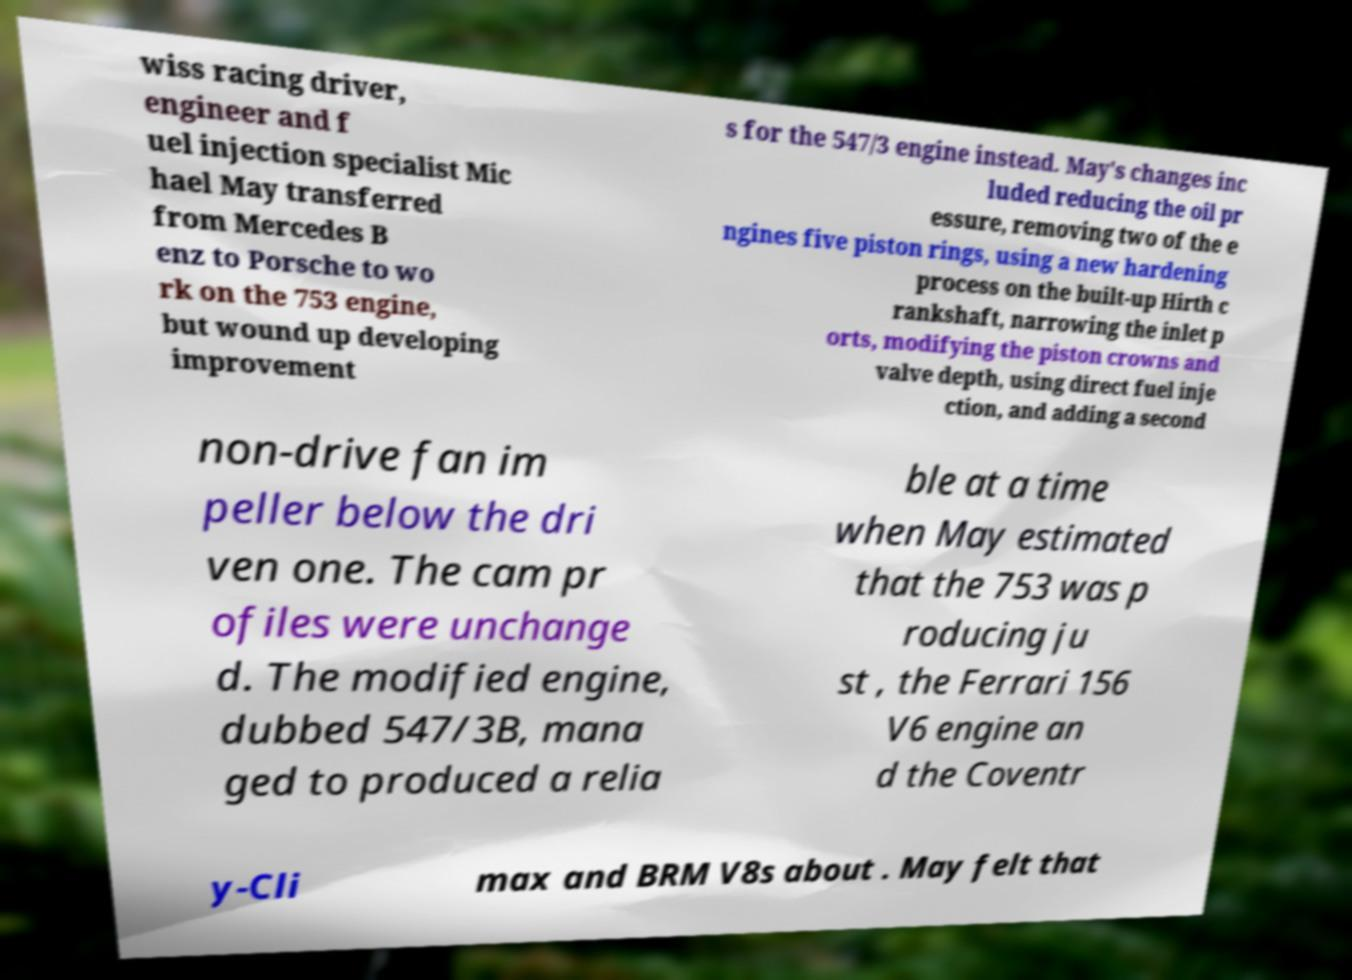Can you read and provide the text displayed in the image?This photo seems to have some interesting text. Can you extract and type it out for me? wiss racing driver, engineer and f uel injection specialist Mic hael May transferred from Mercedes B enz to Porsche to wo rk on the 753 engine, but wound up developing improvement s for the 547/3 engine instead. May's changes inc luded reducing the oil pr essure, removing two of the e ngines five piston rings, using a new hardening process on the built-up Hirth c rankshaft, narrowing the inlet p orts, modifying the piston crowns and valve depth, using direct fuel inje ction, and adding a second non-drive fan im peller below the dri ven one. The cam pr ofiles were unchange d. The modified engine, dubbed 547/3B, mana ged to produced a relia ble at a time when May estimated that the 753 was p roducing ju st , the Ferrari 156 V6 engine an d the Coventr y-Cli max and BRM V8s about . May felt that 